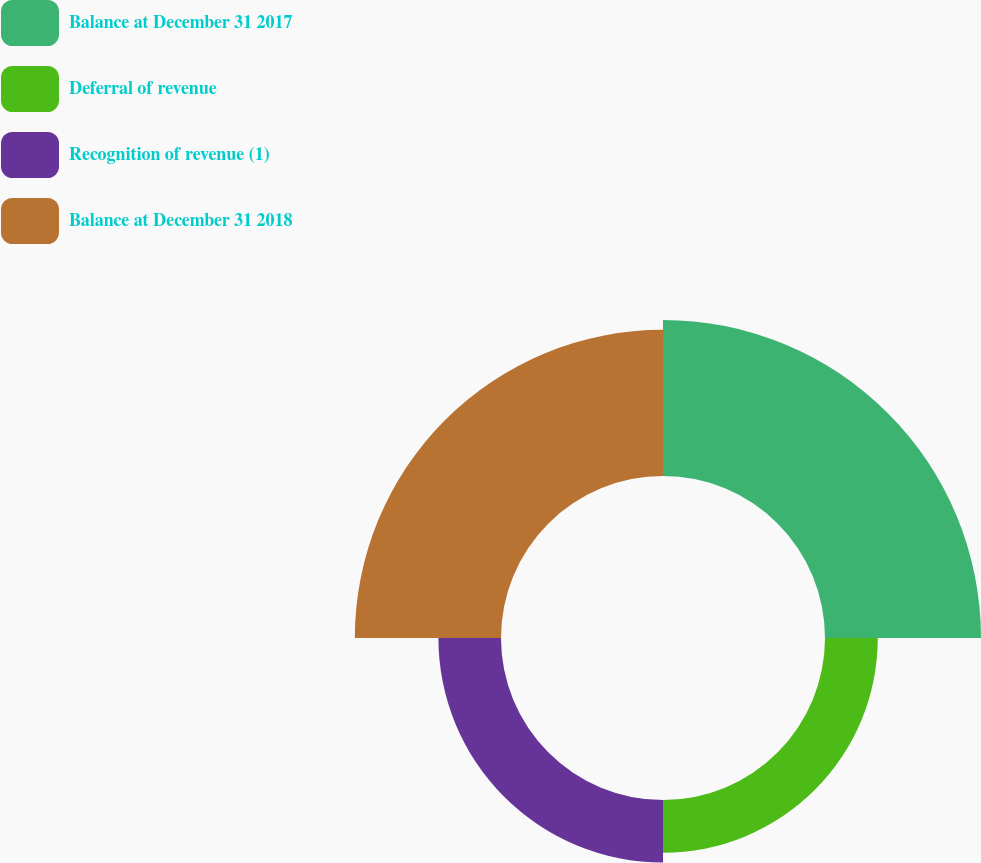<chart> <loc_0><loc_0><loc_500><loc_500><pie_chart><fcel>Balance at December 31 2017<fcel>Deferral of revenue<fcel>Recognition of revenue (1)<fcel>Balance at December 31 2018<nl><fcel>37.36%<fcel>12.64%<fcel>14.99%<fcel>35.01%<nl></chart> 